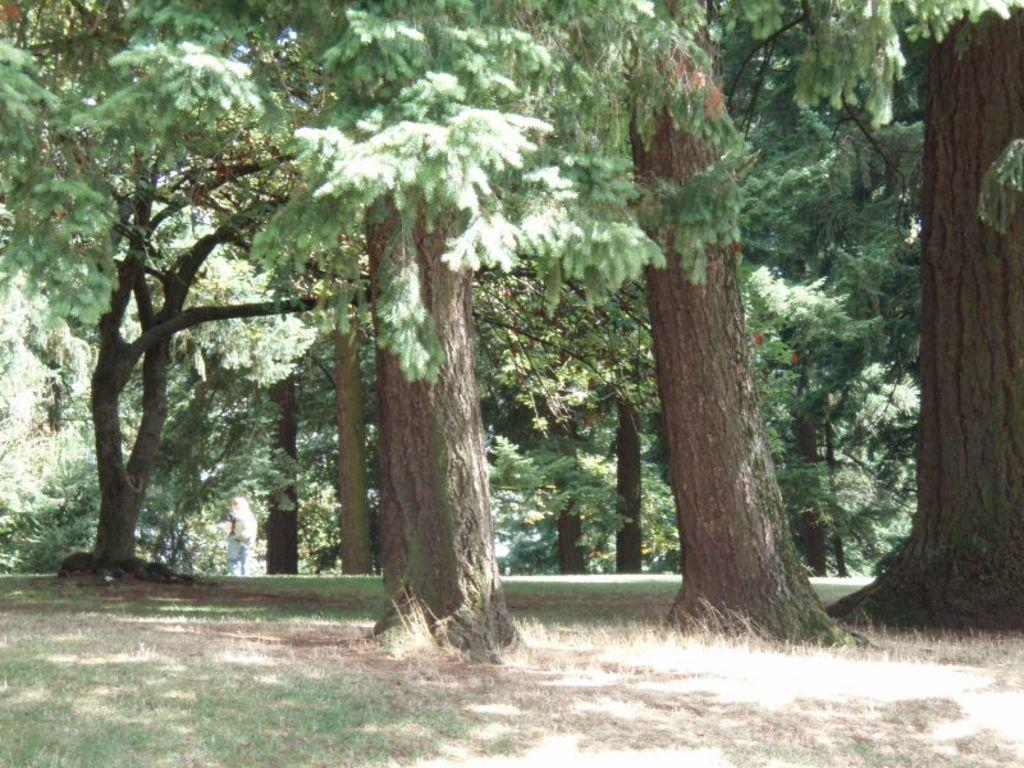What type of vegetation can be seen in the image? There are trees in the image. What part of the natural environment is visible in the image? The ground and grass are visible in the image. Can you describe the object on the ground? Unfortunately, the facts provided do not give enough information to describe the object on the ground. What type of square can be seen in the image? There is no square present in the image. How many roses are visible in the image? There is no rose present in the image. 